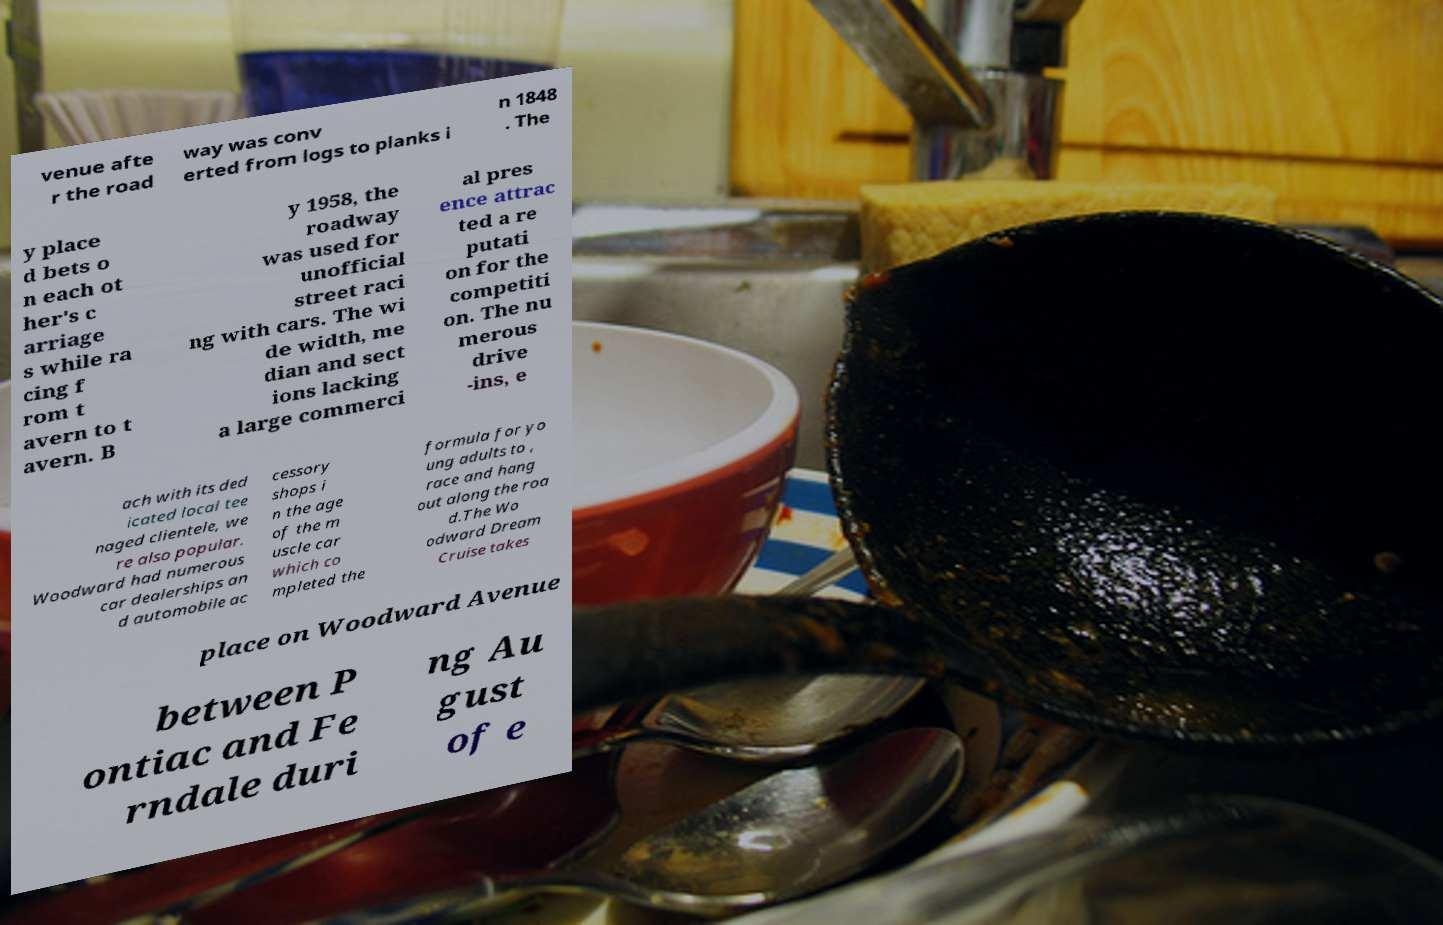For documentation purposes, I need the text within this image transcribed. Could you provide that? venue afte r the road way was conv erted from logs to planks i n 1848 . The y place d bets o n each ot her's c arriage s while ra cing f rom t avern to t avern. B y 1958, the roadway was used for unofficial street raci ng with cars. The wi de width, me dian and sect ions lacking a large commerci al pres ence attrac ted a re putati on for the competiti on. The nu merous drive -ins, e ach with its ded icated local tee naged clientele, we re also popular. Woodward had numerous car dealerships an d automobile ac cessory shops i n the age of the m uscle car which co mpleted the formula for yo ung adults to , race and hang out along the roa d.The Wo odward Dream Cruise takes place on Woodward Avenue between P ontiac and Fe rndale duri ng Au gust of e 